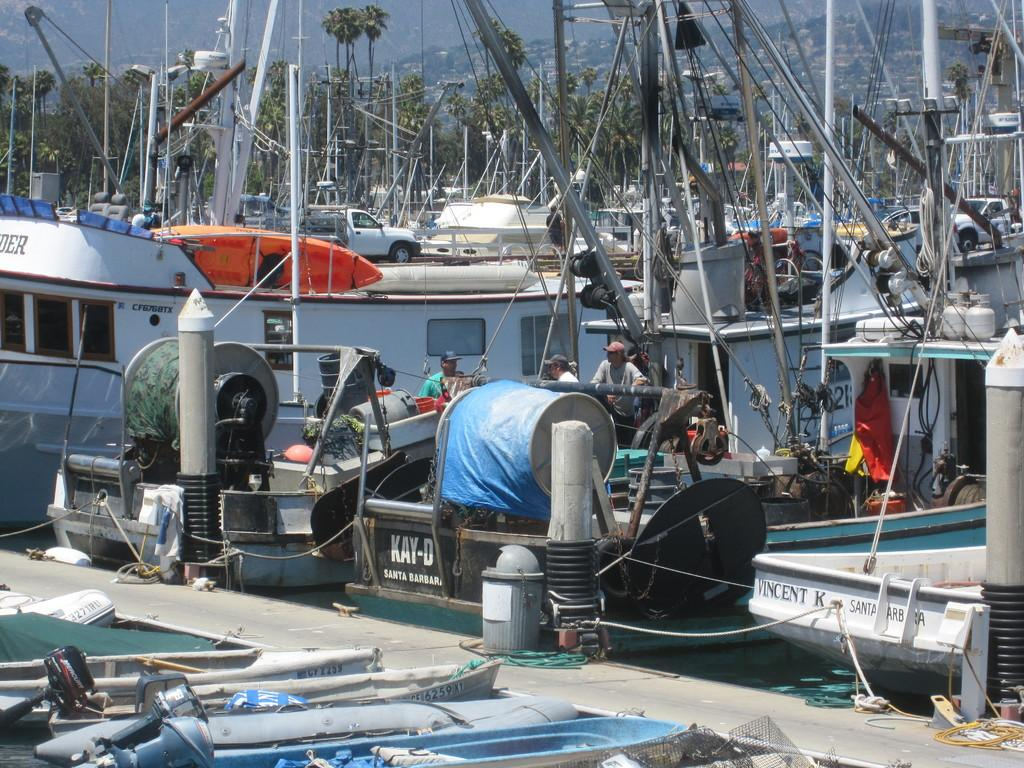What type of vegetation can be seen in the image? There are trees in the image. What objects are present in the water? There are boats in the image. What are the people in the image doing? The people are standing in the water. Can you see a giraffe grazing on the straw in the image? There is no giraffe or straw present in the image. What type of grain is being harvested by the people standing in the water? There is no grain or harvesting activity depicted in the image. 